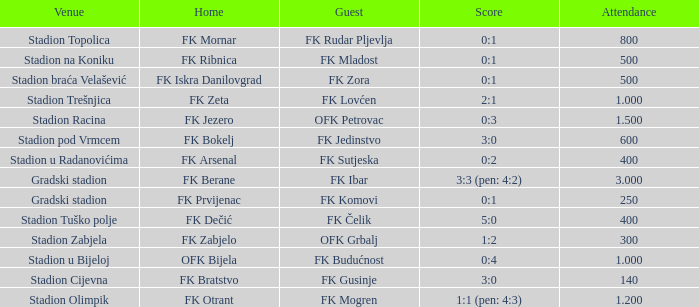What was the score for the game with FK Bratstvo as home team? 3:0. 